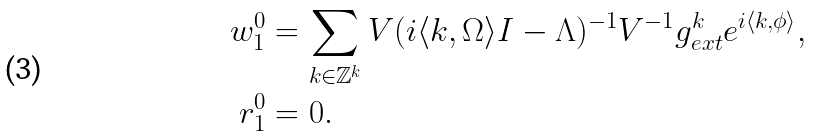<formula> <loc_0><loc_0><loc_500><loc_500>w ^ { 0 } _ { 1 } & = \sum _ { k \in \mathbb { Z } ^ { k } } V ( i \langle k , \Omega \rangle I - \Lambda ) ^ { - 1 } V ^ { - 1 } g _ { e x t } ^ { k } e ^ { i \langle k , \phi \rangle } , \\ r ^ { 0 } _ { 1 } & = 0 .</formula> 